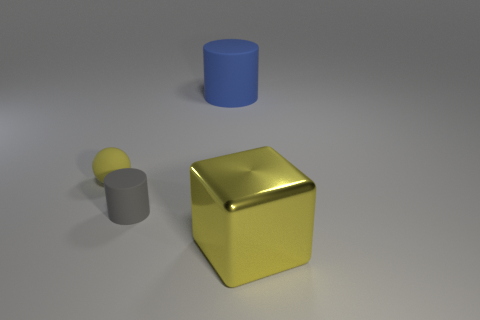Is there any other thing that is made of the same material as the large yellow block?
Your answer should be compact. No. Are there any other things that have the same shape as the metal object?
Ensure brevity in your answer.  No. Are the big block and the yellow thing that is on the left side of the yellow shiny object made of the same material?
Provide a short and direct response. No. Are there more small yellow rubber things that are right of the tiny gray matte cylinder than big blue objects on the right side of the big rubber thing?
Offer a terse response. No. There is a large object right of the matte object right of the gray matte cylinder; what color is it?
Your answer should be compact. Yellow. How many blocks are gray matte objects or large yellow objects?
Provide a short and direct response. 1. How many yellow objects are on the left side of the large cylinder and to the right of the small yellow rubber ball?
Give a very brief answer. 0. What is the color of the big object that is behind the big yellow metal cube?
Offer a terse response. Blue. There is a yellow ball that is the same material as the tiny gray cylinder; what is its size?
Your response must be concise. Small. What number of yellow metallic things are in front of the yellow thing that is behind the yellow metal thing?
Your answer should be compact. 1. 